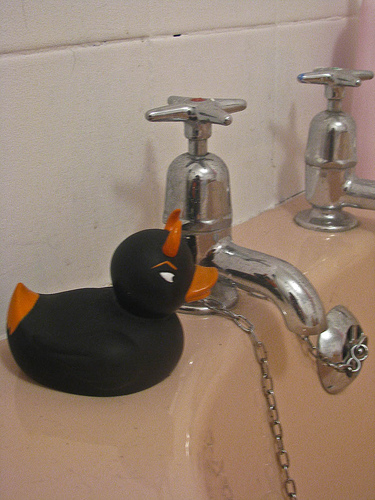<image>
Is there a duck behind the faucet? No. The duck is not behind the faucet. From this viewpoint, the duck appears to be positioned elsewhere in the scene. 